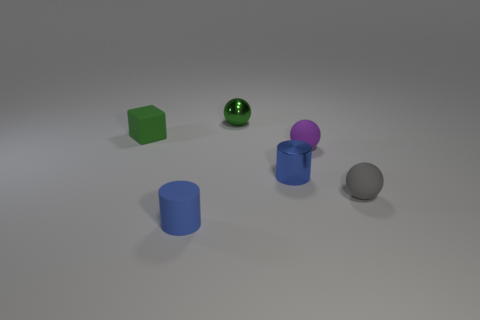Add 1 big metallic blocks. How many objects exist? 7 Subtract all cylinders. How many objects are left? 4 Add 2 green things. How many green things are left? 4 Add 4 green metallic objects. How many green metallic objects exist? 5 Subtract 1 blue cylinders. How many objects are left? 5 Subtract all big brown metal balls. Subtract all green blocks. How many objects are left? 5 